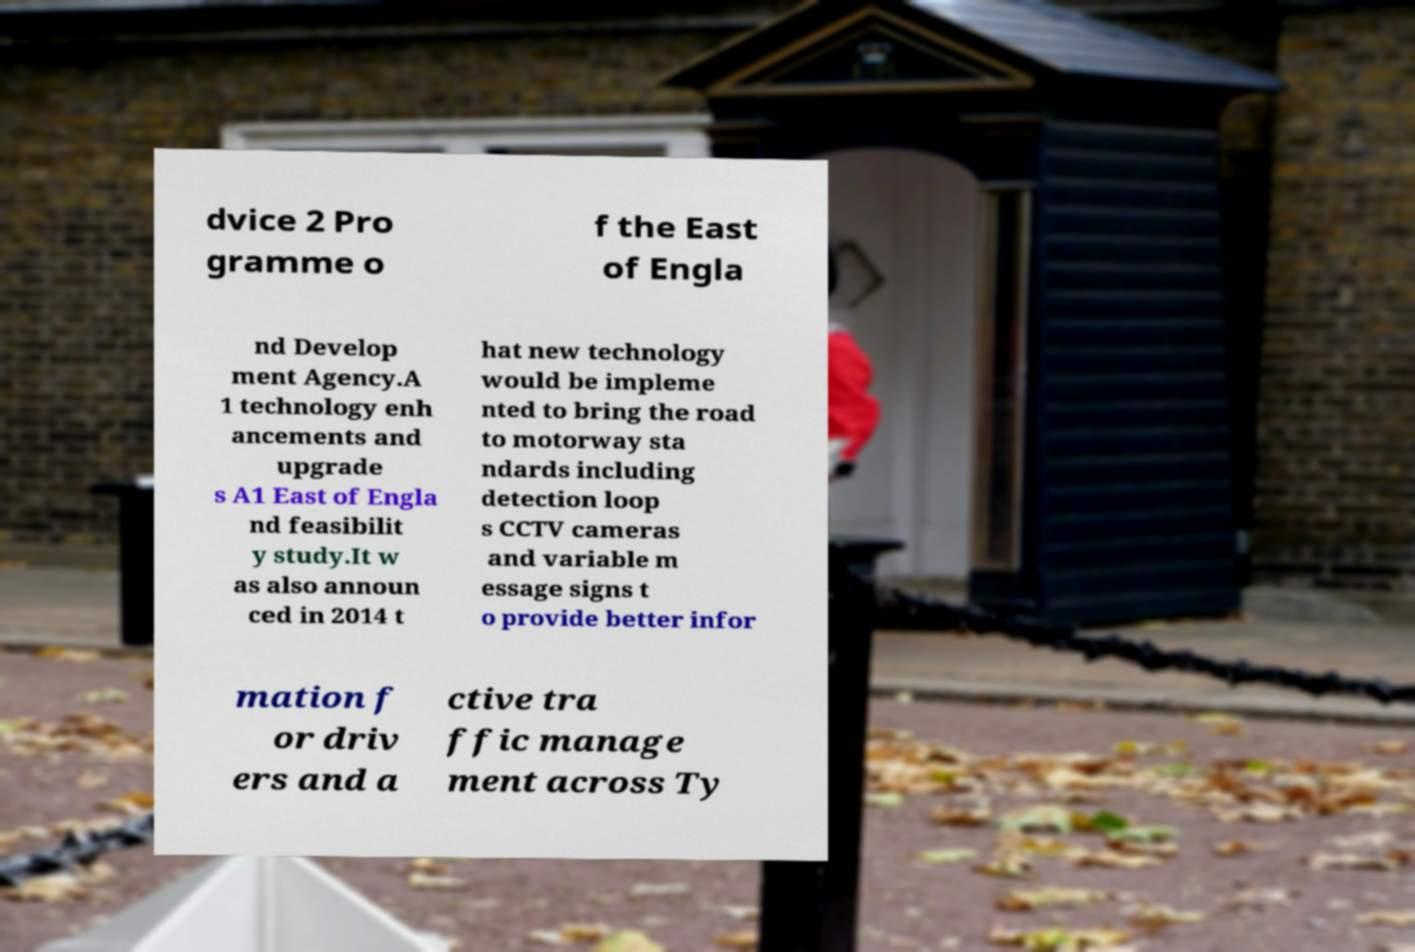Can you read and provide the text displayed in the image?This photo seems to have some interesting text. Can you extract and type it out for me? dvice 2 Pro gramme o f the East of Engla nd Develop ment Agency.A 1 technology enh ancements and upgrade s A1 East of Engla nd feasibilit y study.It w as also announ ced in 2014 t hat new technology would be impleme nted to bring the road to motorway sta ndards including detection loop s CCTV cameras and variable m essage signs t o provide better infor mation f or driv ers and a ctive tra ffic manage ment across Ty 